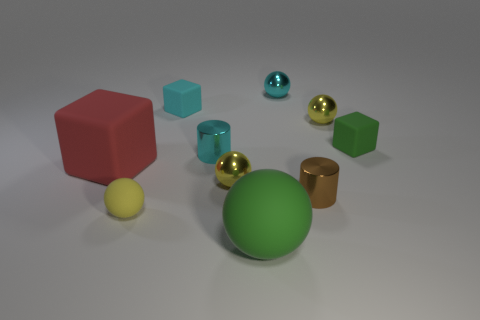The tiny cyan object that is made of the same material as the cyan cylinder is what shape? The tiny cyan object appears to be a sphere, which is reflecting light in a similar manner as the cyan cylinder, indicating that they are both made of a material with reflective properties, likely a glossy finish. 